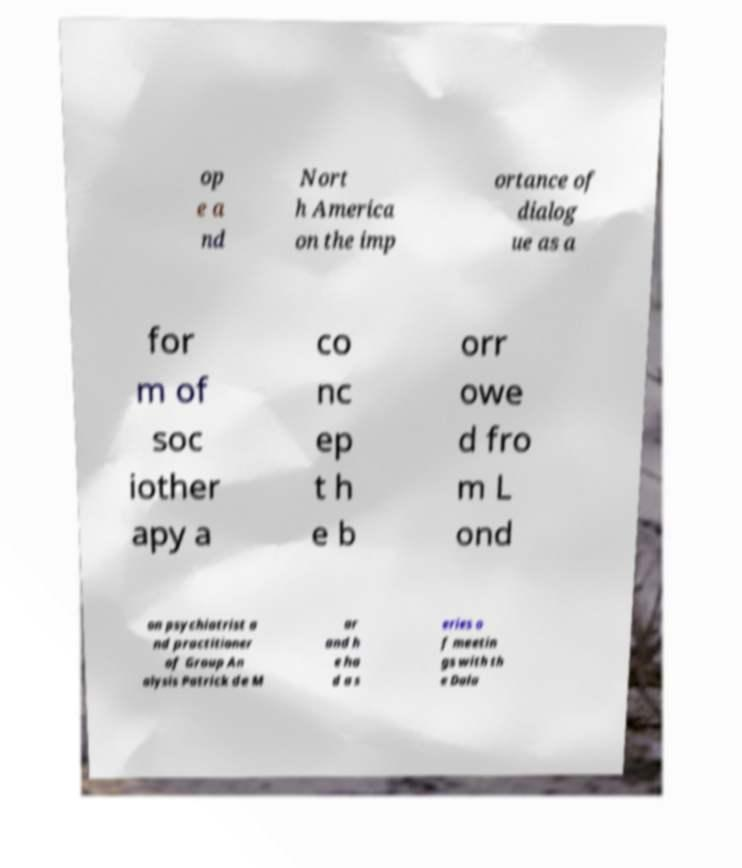Can you accurately transcribe the text from the provided image for me? op e a nd Nort h America on the imp ortance of dialog ue as a for m of soc iother apy a co nc ep t h e b orr owe d fro m L ond on psychiatrist a nd practitioner of Group An alysis Patrick de M ar and h e ha d a s eries o f meetin gs with th e Dala 